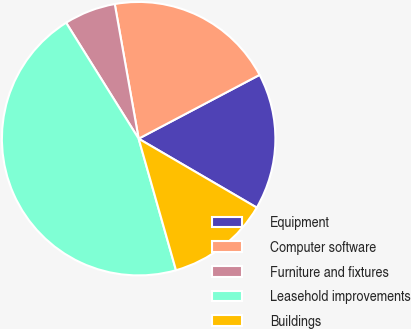Convert chart. <chart><loc_0><loc_0><loc_500><loc_500><pie_chart><fcel>Equipment<fcel>Computer software<fcel>Furniture and fixtures<fcel>Leasehold improvements<fcel>Buildings<nl><fcel>16.13%<fcel>20.07%<fcel>6.1%<fcel>45.51%<fcel>12.19%<nl></chart> 